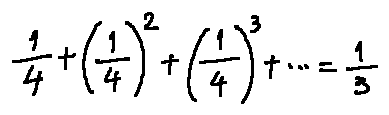<formula> <loc_0><loc_0><loc_500><loc_500>\frac { 1 } { 4 } + ( \frac { 1 } { 4 } ) ^ { 2 } + ( \frac { 1 } { 4 } ) ^ { 3 } + \cdots = \frac { 1 } { 3 }</formula> 